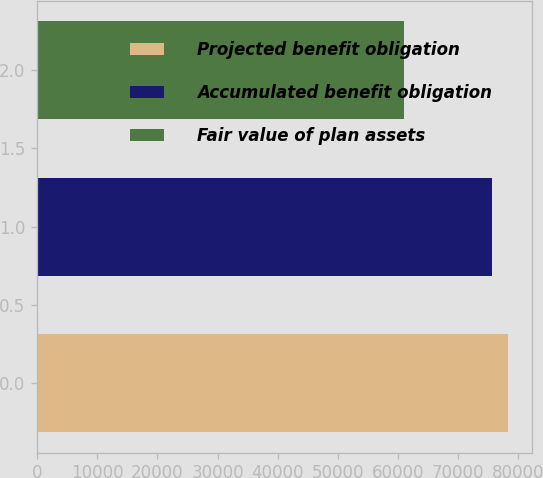<chart> <loc_0><loc_0><loc_500><loc_500><bar_chart><fcel>Projected benefit obligation<fcel>Accumulated benefit obligation<fcel>Fair value of plan assets<nl><fcel>78358<fcel>75622<fcel>61082<nl></chart> 